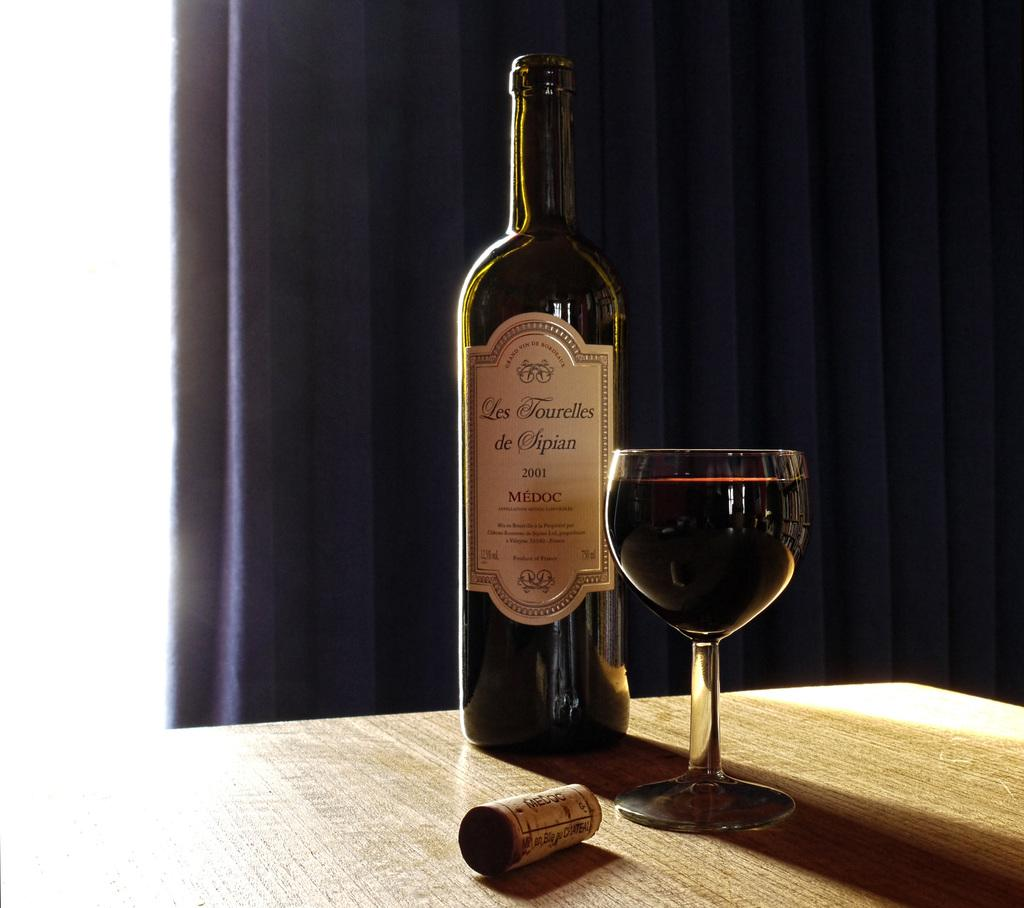Provide a one-sentence caption for the provided image. A full glass and a cork sit in front of a bottle Les Tourelles de Sipian MEDOC year 2001. 